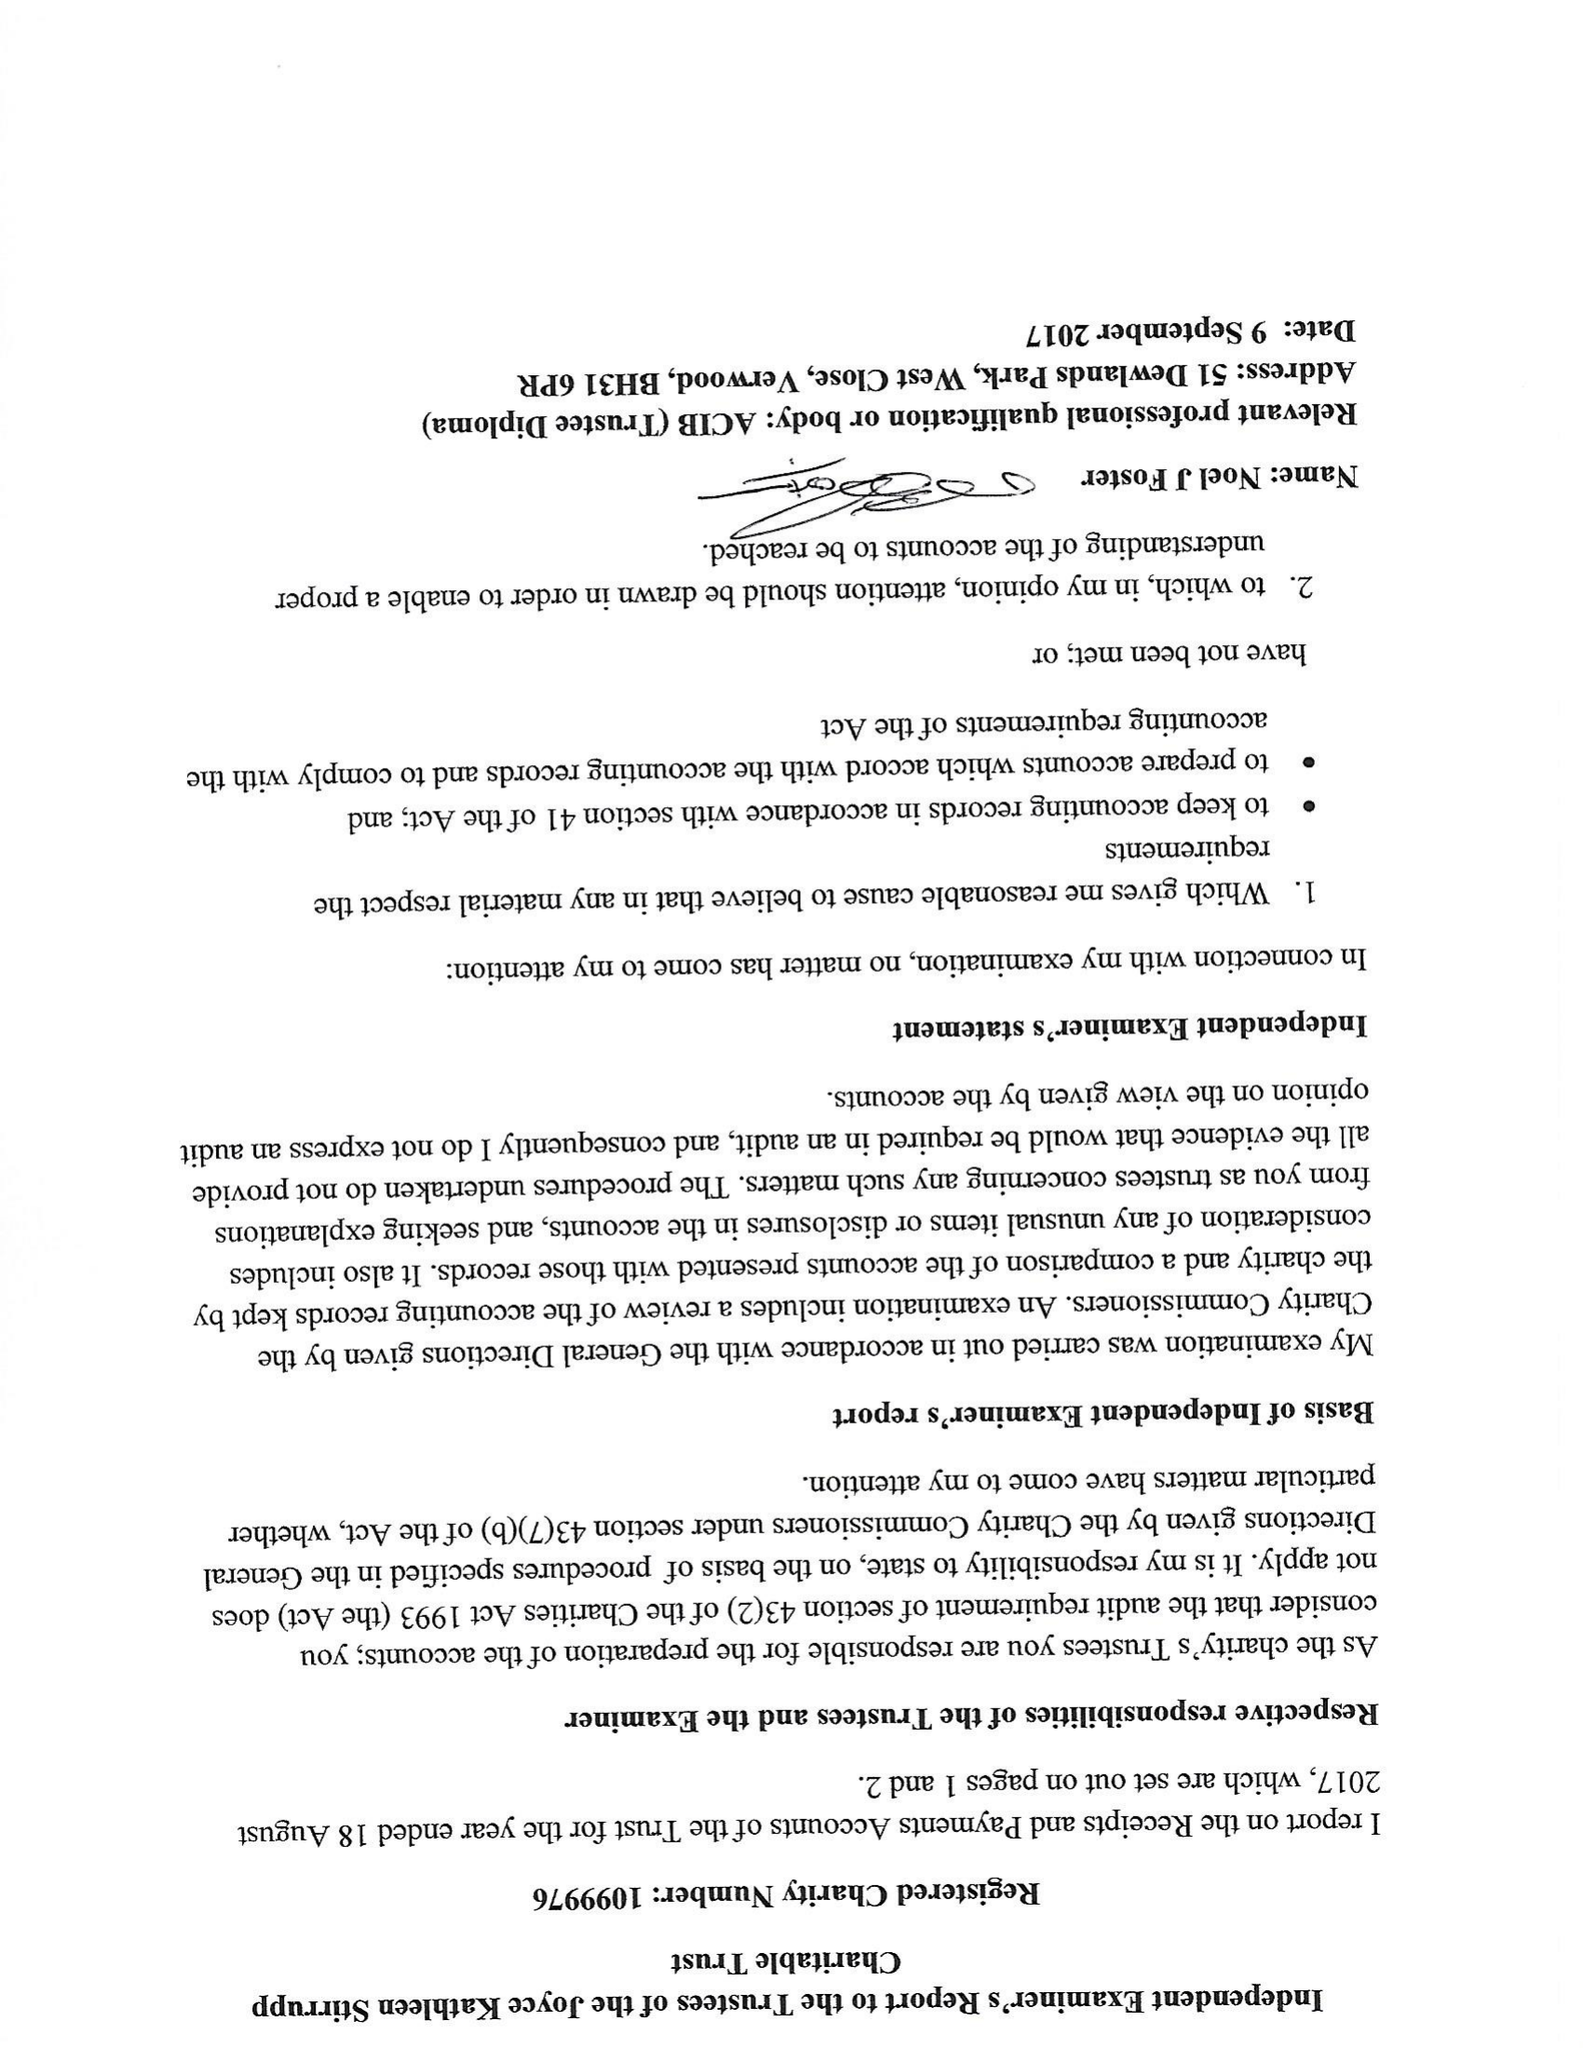What is the value for the charity_number?
Answer the question using a single word or phrase. 1099976 